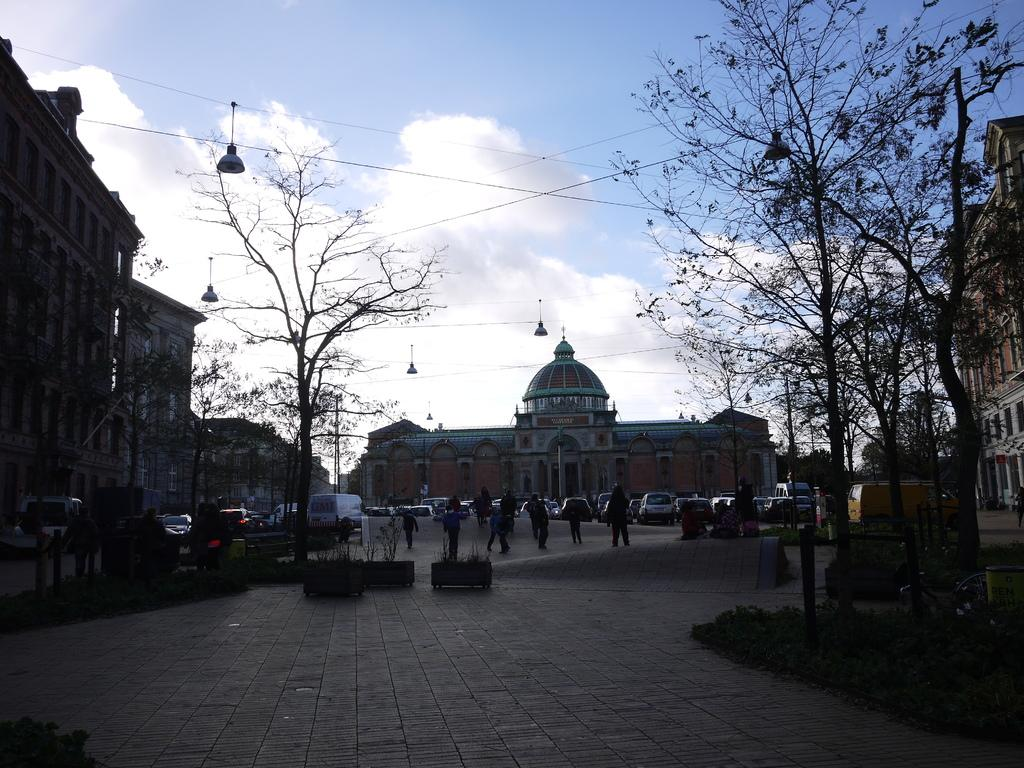How many people are in the group visible in the image? There is a group of people in the image, but the exact number cannot be determined from the provided facts. What types of vehicles can be seen on the road in the image? Vehicles are present on the road in the image, but the specific types cannot be determined from the provided facts. What type of vegetation is present in the image? Trees are present in the image. What type of structures are visible in the image? Buildings are visible in the image. What other objects can be seen in the image? Electric poles are in the image, along with other objects that cannot be identified from the provided facts. What is visible in the background of the image? The sky is visible in the background of the image. What type of beast is seen crossing the bridge in the image? There is no beast or bridge present in the image; it features a group of people, vehicles, trees, buildings, electric poles, and other objects, along with the sky visible in the background. 